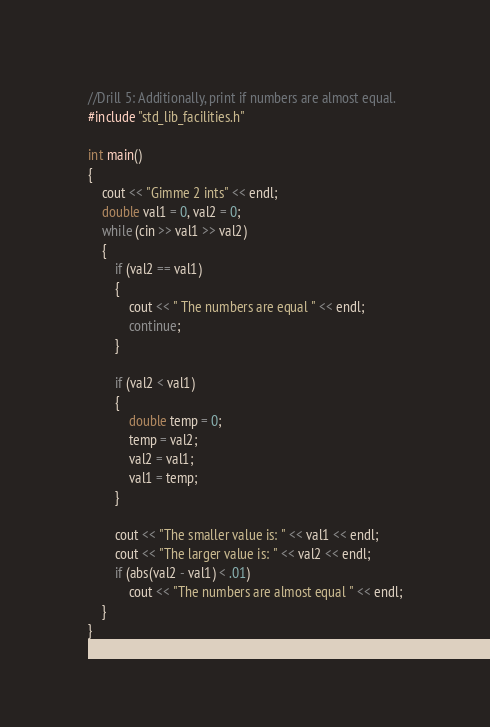<code> <loc_0><loc_0><loc_500><loc_500><_C++_>//Drill 5: Additionally, print if numbers are almost equal.
#include "std_lib_facilities.h"

int main()
{
	cout << "Gimme 2 ints" << endl;
	double val1 = 0, val2 = 0;
	while (cin >> val1 >> val2)
	{
		if (val2 == val1)
		{
			cout << " The numbers are equal " << endl;
			continue;
		}

		if (val2 < val1)
		{
			double temp = 0;
			temp = val2;
			val2 = val1;
			val1 = temp;
		}

		cout << "The smaller value is: " << val1 << endl;
		cout << "The larger value is: " << val2 << endl;
		if (abs(val2 - val1) < .01)
			cout << "The numbers are almost equal " << endl;
	}
}
</code> 